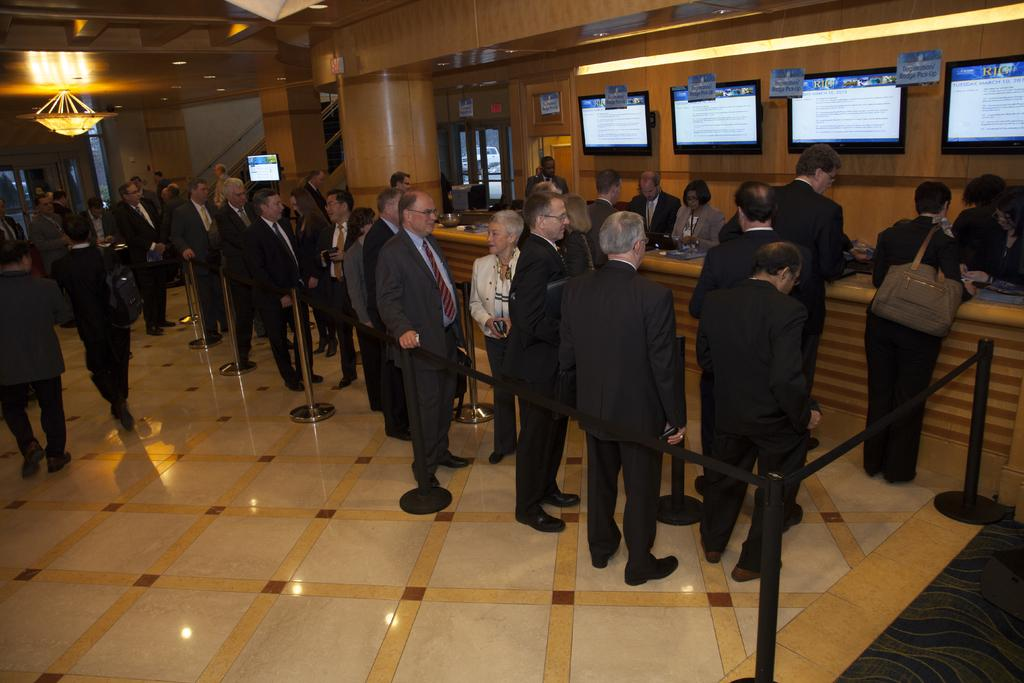What is the main subject of the image? The main subject of the image is a group of people standing. What can be seen in the image besides the people? There are rope barriers, televisions, and a chandelier in the image. What type of advertisement can be seen on the chandelier in the image? There is no advertisement present on the chandelier in the image. 